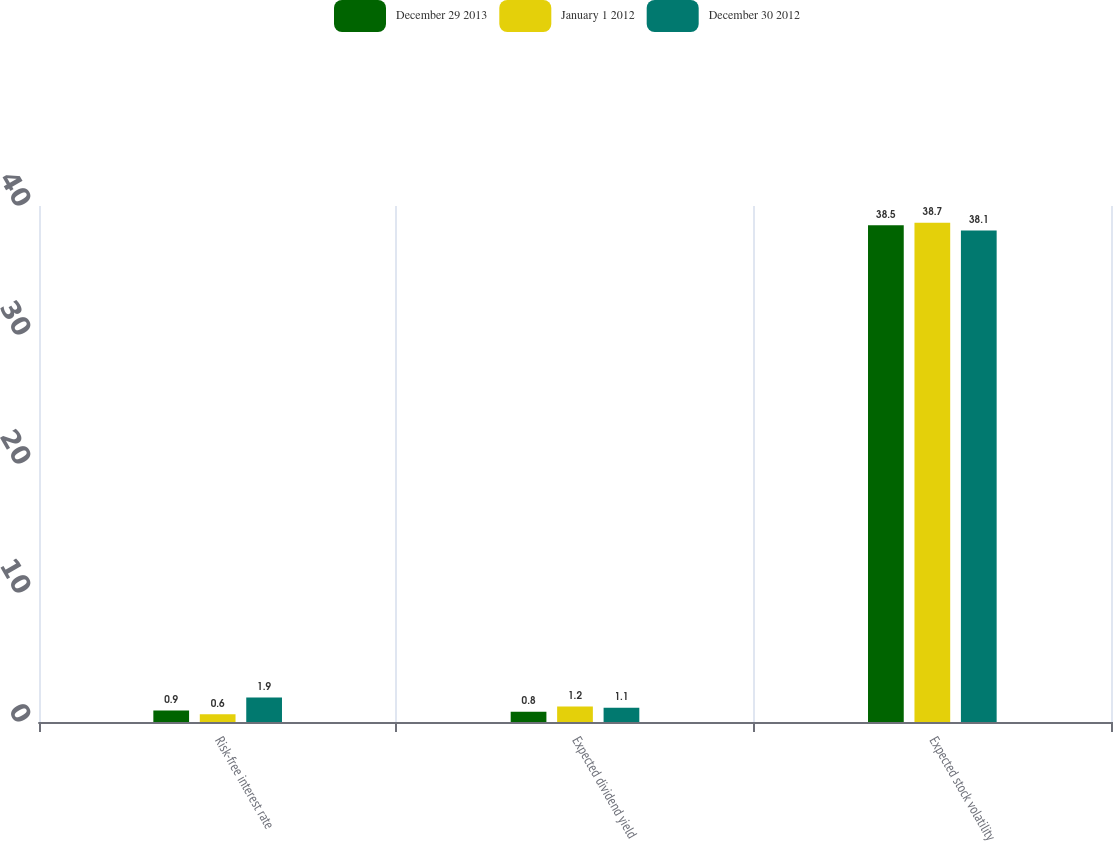Convert chart to OTSL. <chart><loc_0><loc_0><loc_500><loc_500><stacked_bar_chart><ecel><fcel>Risk-free interest rate<fcel>Expected dividend yield<fcel>Expected stock volatility<nl><fcel>December 29 2013<fcel>0.9<fcel>0.8<fcel>38.5<nl><fcel>January 1 2012<fcel>0.6<fcel>1.2<fcel>38.7<nl><fcel>December 30 2012<fcel>1.9<fcel>1.1<fcel>38.1<nl></chart> 